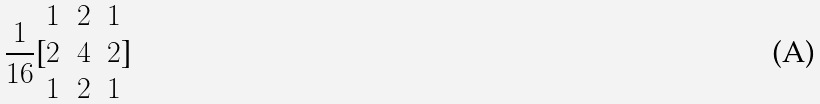<formula> <loc_0><loc_0><loc_500><loc_500>\frac { 1 } { 1 6 } [ \begin{matrix} 1 & 2 & 1 \\ 2 & 4 & 2 \\ 1 & 2 & 1 \end{matrix} ]</formula> 